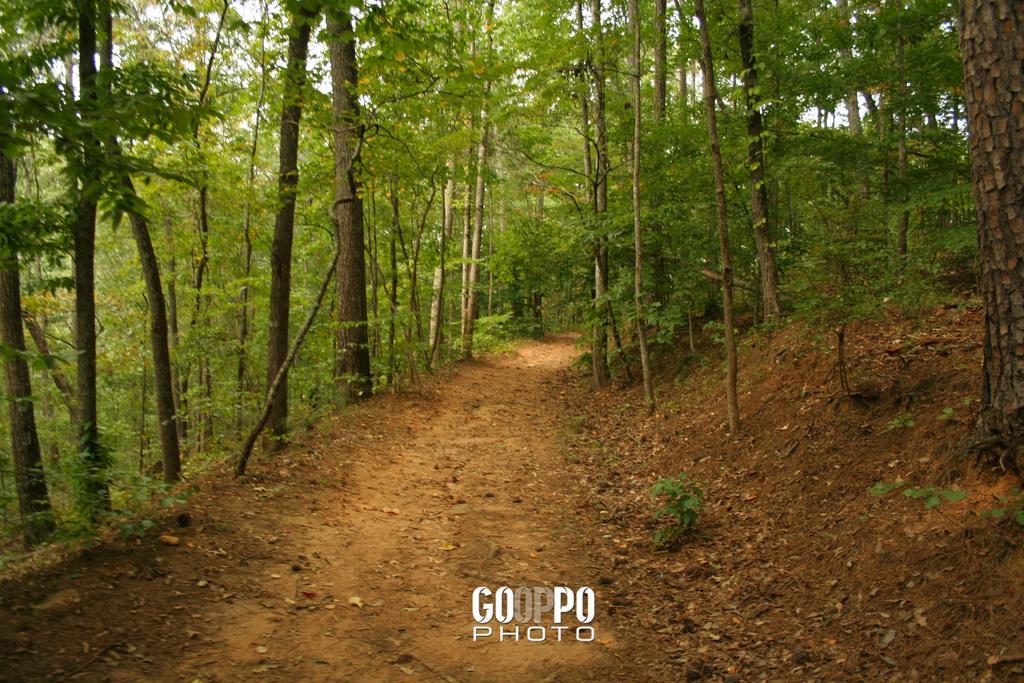In one or two sentences, can you explain what this image depicts? At the center of the image there is a path and both the left and right side of the image there are trees. 